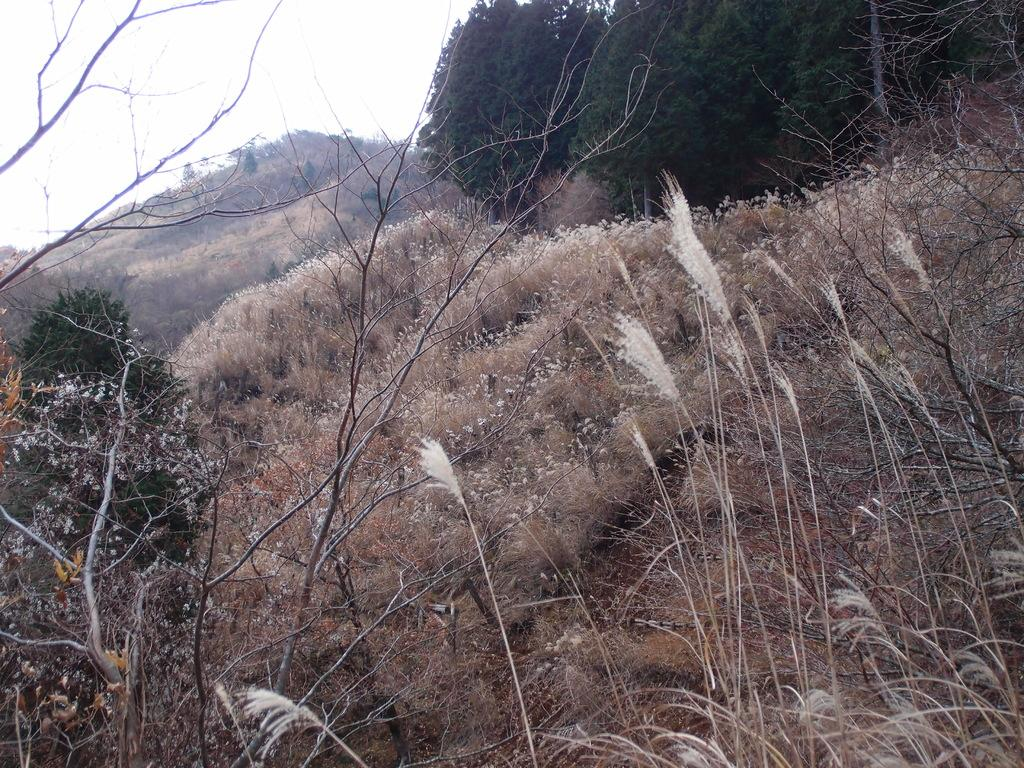What type of living organisms can be seen in the image? Plants are visible in the image. What is the condition of the ground in the image? Dry grass is present on the ground. What can be seen in the background of the image? There are trees in the background of the image. What is visible at the top of the image? The sky is visible at the top of the image. What type of rhythm can be heard coming from the plants in the image? There is no sound or rhythm associated with the plants in the image. 